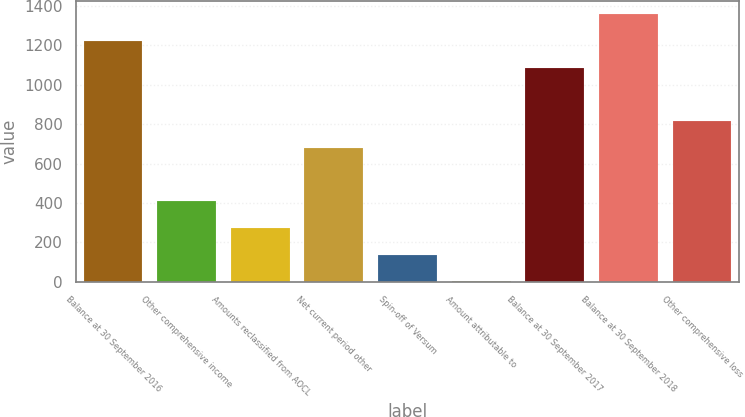Convert chart. <chart><loc_0><loc_0><loc_500><loc_500><bar_chart><fcel>Balance at 30 September 2016<fcel>Other comprehensive income<fcel>Amounts reclassified from AOCL<fcel>Net current period other<fcel>Spin-off of Versum<fcel>Amount attributable to<fcel>Balance at 30 September 2017<fcel>Balance at 30 September 2018<fcel>Other comprehensive loss<nl><fcel>1221.51<fcel>409.17<fcel>273.78<fcel>679.95<fcel>138.39<fcel>3<fcel>1086.12<fcel>1356.9<fcel>815.34<nl></chart> 